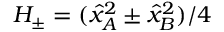Convert formula to latex. <formula><loc_0><loc_0><loc_500><loc_500>H _ { \pm } = ( \hat { x } _ { A } ^ { 2 } \pm \hat { x } _ { B } ^ { 2 } ) / 4</formula> 